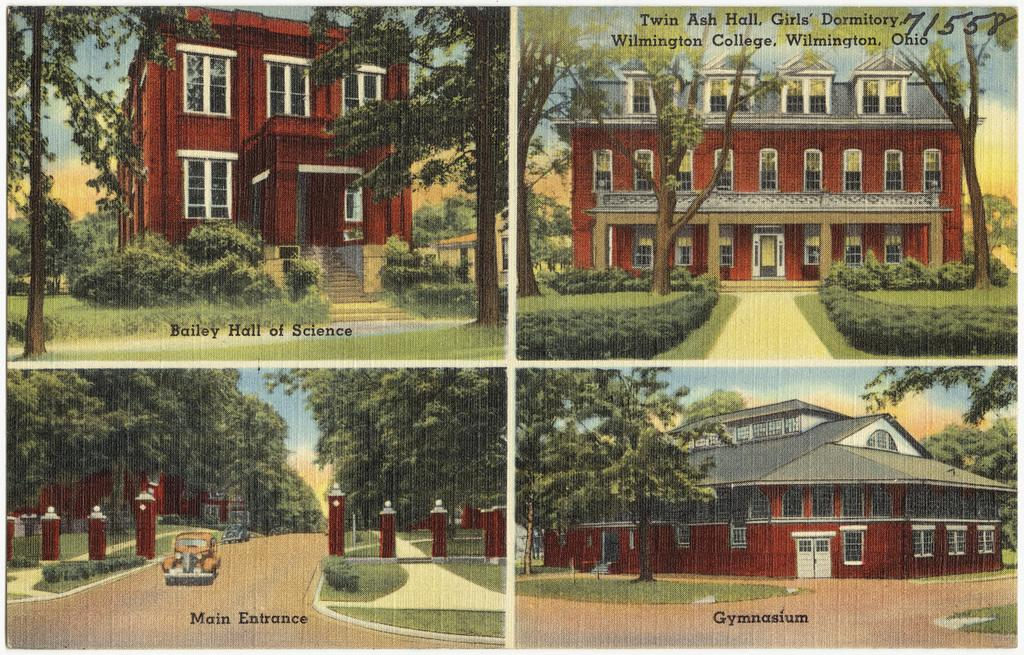What type of artwork is depicted in the image? The image contains a collage of various elements. What structures can be seen in the collage? There are buildings in the collage. What type of vegetation is present in the collage? There are trees and grass in the collage. What part of the natural environment is visible in the collage? The sky is visible in the collage. What is the mode of transportation visible in the collage? There is a vehicle on the road in the collage. Is there any text present in the image? Yes, there is text written on the picture. How many dogs are playing with the grain in the image? There are no dogs or grain present in the image. What type of bat is flying in the sky in the image? There are no bats present in the image; only buildings, trees, grass, sky, vehicle, and text are visible. 